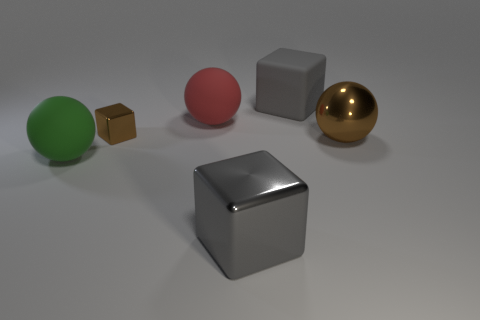There is a metal cube to the right of the red sphere; does it have the same size as the gray block that is behind the large gray metallic cube?
Offer a very short reply. Yes. What size is the gray thing in front of the red object?
Give a very brief answer. Large. Are there any other cubes that have the same color as the big matte block?
Provide a short and direct response. Yes. There is a large object on the left side of the small brown cube; are there any gray blocks that are behind it?
Offer a terse response. Yes. There is a gray rubber cube; is it the same size as the metal cube behind the large brown thing?
Your answer should be very brief. No. Is there a brown metal block to the right of the big rubber ball that is in front of the brown metal object that is behind the big brown object?
Make the answer very short. Yes. What is the ball in front of the big brown object made of?
Provide a succinct answer. Rubber. Is the metallic ball the same size as the green ball?
Make the answer very short. Yes. There is a large thing that is both right of the tiny brown cube and in front of the big metallic ball; what color is it?
Make the answer very short. Gray. The green thing that is made of the same material as the red thing is what shape?
Offer a terse response. Sphere. 